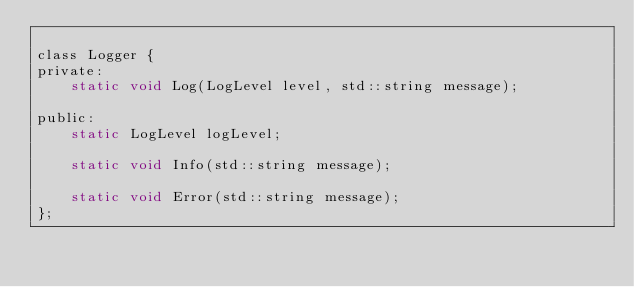<code> <loc_0><loc_0><loc_500><loc_500><_C_>
class Logger {
private:
    static void Log(LogLevel level, std::string message);

public:
    static LogLevel logLevel;

    static void Info(std::string message);

    static void Error(std::string message);
};</code> 